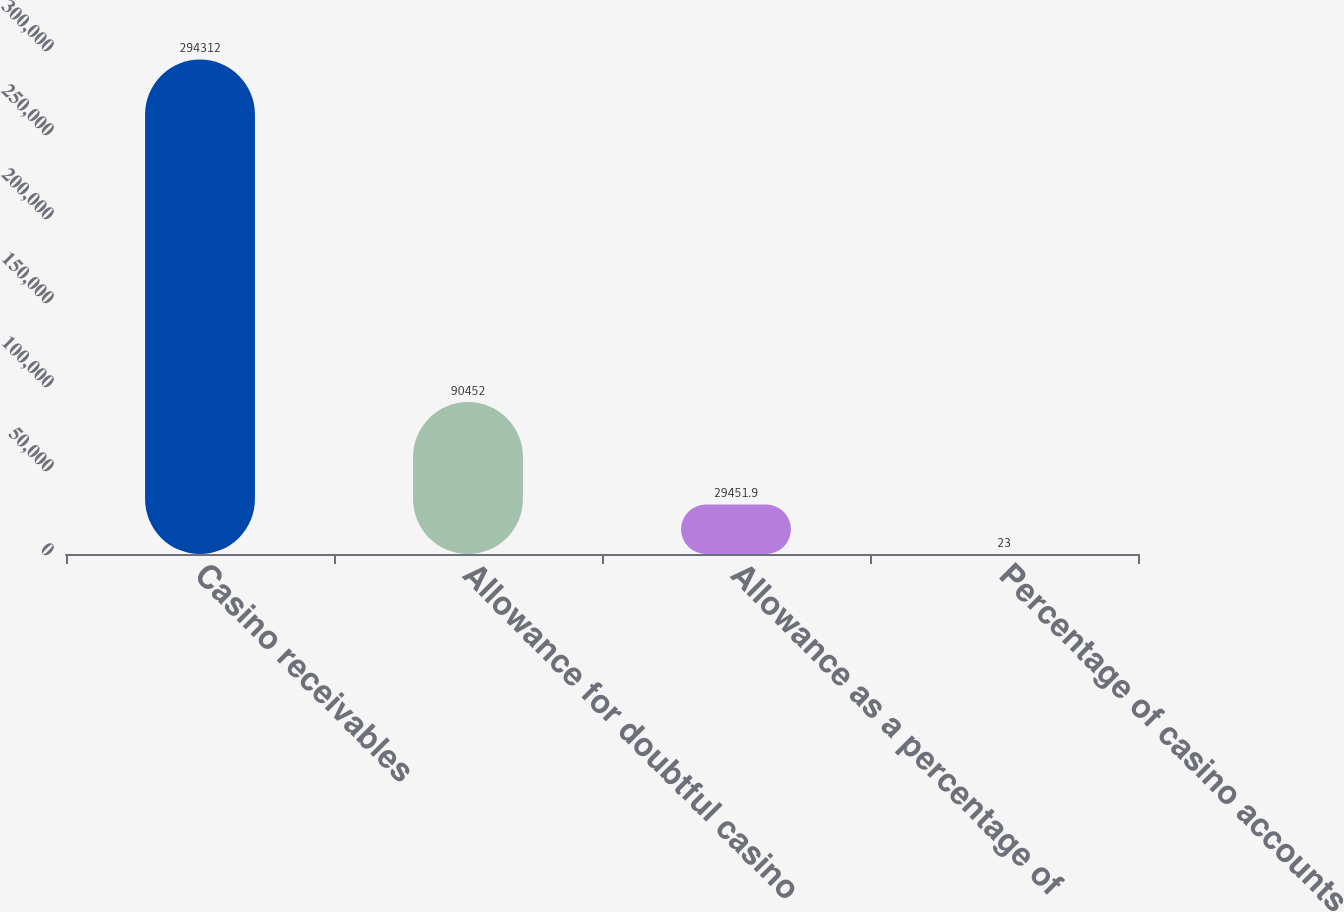Convert chart. <chart><loc_0><loc_0><loc_500><loc_500><bar_chart><fcel>Casino receivables<fcel>Allowance for doubtful casino<fcel>Allowance as a percentage of<fcel>Percentage of casino accounts<nl><fcel>294312<fcel>90452<fcel>29451.9<fcel>23<nl></chart> 